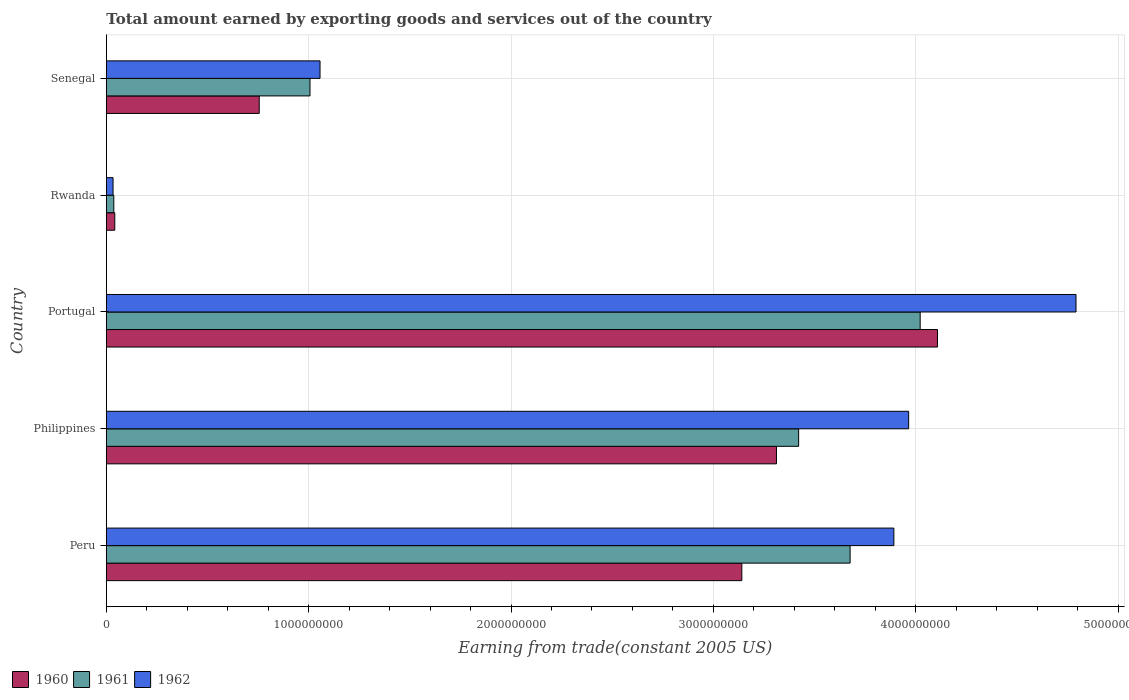How many groups of bars are there?
Provide a succinct answer. 5. Are the number of bars per tick equal to the number of legend labels?
Your response must be concise. Yes. Are the number of bars on each tick of the Y-axis equal?
Make the answer very short. Yes. How many bars are there on the 4th tick from the top?
Your response must be concise. 3. What is the total amount earned by exporting goods and services in 1960 in Portugal?
Your answer should be compact. 4.11e+09. Across all countries, what is the maximum total amount earned by exporting goods and services in 1961?
Give a very brief answer. 4.02e+09. Across all countries, what is the minimum total amount earned by exporting goods and services in 1961?
Ensure brevity in your answer.  3.69e+07. In which country was the total amount earned by exporting goods and services in 1960 maximum?
Provide a succinct answer. Portugal. In which country was the total amount earned by exporting goods and services in 1960 minimum?
Make the answer very short. Rwanda. What is the total total amount earned by exporting goods and services in 1960 in the graph?
Ensure brevity in your answer.  1.14e+1. What is the difference between the total amount earned by exporting goods and services in 1962 in Philippines and that in Rwanda?
Offer a very short reply. 3.93e+09. What is the difference between the total amount earned by exporting goods and services in 1962 in Philippines and the total amount earned by exporting goods and services in 1961 in Senegal?
Keep it short and to the point. 2.96e+09. What is the average total amount earned by exporting goods and services in 1961 per country?
Provide a short and direct response. 2.43e+09. What is the difference between the total amount earned by exporting goods and services in 1961 and total amount earned by exporting goods and services in 1960 in Portugal?
Keep it short and to the point. -8.56e+07. What is the ratio of the total amount earned by exporting goods and services in 1961 in Philippines to that in Rwanda?
Your response must be concise. 92.77. Is the total amount earned by exporting goods and services in 1961 in Peru less than that in Philippines?
Offer a very short reply. No. What is the difference between the highest and the second highest total amount earned by exporting goods and services in 1960?
Provide a succinct answer. 7.96e+08. What is the difference between the highest and the lowest total amount earned by exporting goods and services in 1961?
Your answer should be very brief. 3.98e+09. In how many countries, is the total amount earned by exporting goods and services in 1962 greater than the average total amount earned by exporting goods and services in 1962 taken over all countries?
Provide a short and direct response. 3. Is it the case that in every country, the sum of the total amount earned by exporting goods and services in 1962 and total amount earned by exporting goods and services in 1961 is greater than the total amount earned by exporting goods and services in 1960?
Your answer should be compact. Yes. How many bars are there?
Provide a succinct answer. 15. Are all the bars in the graph horizontal?
Your answer should be very brief. Yes. How many countries are there in the graph?
Your answer should be very brief. 5. Are the values on the major ticks of X-axis written in scientific E-notation?
Your answer should be very brief. No. Does the graph contain any zero values?
Provide a short and direct response. No. Does the graph contain grids?
Your answer should be compact. Yes. Where does the legend appear in the graph?
Make the answer very short. Bottom left. How many legend labels are there?
Your answer should be very brief. 3. What is the title of the graph?
Offer a terse response. Total amount earned by exporting goods and services out of the country. What is the label or title of the X-axis?
Provide a succinct answer. Earning from trade(constant 2005 US). What is the label or title of the Y-axis?
Give a very brief answer. Country. What is the Earning from trade(constant 2005 US) in 1960 in Peru?
Offer a terse response. 3.14e+09. What is the Earning from trade(constant 2005 US) in 1961 in Peru?
Give a very brief answer. 3.68e+09. What is the Earning from trade(constant 2005 US) in 1962 in Peru?
Offer a terse response. 3.89e+09. What is the Earning from trade(constant 2005 US) of 1960 in Philippines?
Keep it short and to the point. 3.31e+09. What is the Earning from trade(constant 2005 US) in 1961 in Philippines?
Give a very brief answer. 3.42e+09. What is the Earning from trade(constant 2005 US) in 1962 in Philippines?
Your answer should be compact. 3.97e+09. What is the Earning from trade(constant 2005 US) of 1960 in Portugal?
Offer a terse response. 4.11e+09. What is the Earning from trade(constant 2005 US) in 1961 in Portugal?
Make the answer very short. 4.02e+09. What is the Earning from trade(constant 2005 US) in 1962 in Portugal?
Provide a succinct answer. 4.79e+09. What is the Earning from trade(constant 2005 US) in 1960 in Rwanda?
Your answer should be compact. 4.18e+07. What is the Earning from trade(constant 2005 US) of 1961 in Rwanda?
Your answer should be compact. 3.69e+07. What is the Earning from trade(constant 2005 US) of 1962 in Rwanda?
Offer a very short reply. 3.32e+07. What is the Earning from trade(constant 2005 US) in 1960 in Senegal?
Ensure brevity in your answer.  7.56e+08. What is the Earning from trade(constant 2005 US) of 1961 in Senegal?
Give a very brief answer. 1.01e+09. What is the Earning from trade(constant 2005 US) in 1962 in Senegal?
Keep it short and to the point. 1.06e+09. Across all countries, what is the maximum Earning from trade(constant 2005 US) of 1960?
Offer a terse response. 4.11e+09. Across all countries, what is the maximum Earning from trade(constant 2005 US) of 1961?
Your response must be concise. 4.02e+09. Across all countries, what is the maximum Earning from trade(constant 2005 US) of 1962?
Provide a succinct answer. 4.79e+09. Across all countries, what is the minimum Earning from trade(constant 2005 US) in 1960?
Your response must be concise. 4.18e+07. Across all countries, what is the minimum Earning from trade(constant 2005 US) of 1961?
Provide a succinct answer. 3.69e+07. Across all countries, what is the minimum Earning from trade(constant 2005 US) in 1962?
Offer a very short reply. 3.32e+07. What is the total Earning from trade(constant 2005 US) in 1960 in the graph?
Provide a succinct answer. 1.14e+1. What is the total Earning from trade(constant 2005 US) of 1961 in the graph?
Your answer should be compact. 1.22e+1. What is the total Earning from trade(constant 2005 US) of 1962 in the graph?
Make the answer very short. 1.37e+1. What is the difference between the Earning from trade(constant 2005 US) of 1960 in Peru and that in Philippines?
Your answer should be very brief. -1.71e+08. What is the difference between the Earning from trade(constant 2005 US) in 1961 in Peru and that in Philippines?
Offer a terse response. 2.54e+08. What is the difference between the Earning from trade(constant 2005 US) of 1962 in Peru and that in Philippines?
Offer a very short reply. -7.32e+07. What is the difference between the Earning from trade(constant 2005 US) in 1960 in Peru and that in Portugal?
Offer a very short reply. -9.67e+08. What is the difference between the Earning from trade(constant 2005 US) of 1961 in Peru and that in Portugal?
Keep it short and to the point. -3.46e+08. What is the difference between the Earning from trade(constant 2005 US) of 1962 in Peru and that in Portugal?
Offer a very short reply. -9.00e+08. What is the difference between the Earning from trade(constant 2005 US) in 1960 in Peru and that in Rwanda?
Keep it short and to the point. 3.10e+09. What is the difference between the Earning from trade(constant 2005 US) of 1961 in Peru and that in Rwanda?
Give a very brief answer. 3.64e+09. What is the difference between the Earning from trade(constant 2005 US) in 1962 in Peru and that in Rwanda?
Make the answer very short. 3.86e+09. What is the difference between the Earning from trade(constant 2005 US) in 1960 in Peru and that in Senegal?
Your response must be concise. 2.38e+09. What is the difference between the Earning from trade(constant 2005 US) in 1961 in Peru and that in Senegal?
Provide a succinct answer. 2.67e+09. What is the difference between the Earning from trade(constant 2005 US) in 1962 in Peru and that in Senegal?
Ensure brevity in your answer.  2.84e+09. What is the difference between the Earning from trade(constant 2005 US) in 1960 in Philippines and that in Portugal?
Your response must be concise. -7.96e+08. What is the difference between the Earning from trade(constant 2005 US) in 1961 in Philippines and that in Portugal?
Offer a very short reply. -6.01e+08. What is the difference between the Earning from trade(constant 2005 US) in 1962 in Philippines and that in Portugal?
Offer a terse response. -8.27e+08. What is the difference between the Earning from trade(constant 2005 US) in 1960 in Philippines and that in Rwanda?
Keep it short and to the point. 3.27e+09. What is the difference between the Earning from trade(constant 2005 US) of 1961 in Philippines and that in Rwanda?
Your answer should be compact. 3.38e+09. What is the difference between the Earning from trade(constant 2005 US) of 1962 in Philippines and that in Rwanda?
Ensure brevity in your answer.  3.93e+09. What is the difference between the Earning from trade(constant 2005 US) of 1960 in Philippines and that in Senegal?
Ensure brevity in your answer.  2.56e+09. What is the difference between the Earning from trade(constant 2005 US) of 1961 in Philippines and that in Senegal?
Your response must be concise. 2.41e+09. What is the difference between the Earning from trade(constant 2005 US) in 1962 in Philippines and that in Senegal?
Offer a terse response. 2.91e+09. What is the difference between the Earning from trade(constant 2005 US) of 1960 in Portugal and that in Rwanda?
Keep it short and to the point. 4.07e+09. What is the difference between the Earning from trade(constant 2005 US) of 1961 in Portugal and that in Rwanda?
Your answer should be very brief. 3.98e+09. What is the difference between the Earning from trade(constant 2005 US) of 1962 in Portugal and that in Rwanda?
Offer a very short reply. 4.76e+09. What is the difference between the Earning from trade(constant 2005 US) of 1960 in Portugal and that in Senegal?
Provide a short and direct response. 3.35e+09. What is the difference between the Earning from trade(constant 2005 US) of 1961 in Portugal and that in Senegal?
Offer a terse response. 3.02e+09. What is the difference between the Earning from trade(constant 2005 US) of 1962 in Portugal and that in Senegal?
Keep it short and to the point. 3.74e+09. What is the difference between the Earning from trade(constant 2005 US) of 1960 in Rwanda and that in Senegal?
Keep it short and to the point. -7.14e+08. What is the difference between the Earning from trade(constant 2005 US) of 1961 in Rwanda and that in Senegal?
Offer a very short reply. -9.70e+08. What is the difference between the Earning from trade(constant 2005 US) of 1962 in Rwanda and that in Senegal?
Make the answer very short. -1.02e+09. What is the difference between the Earning from trade(constant 2005 US) of 1960 in Peru and the Earning from trade(constant 2005 US) of 1961 in Philippines?
Offer a terse response. -2.81e+08. What is the difference between the Earning from trade(constant 2005 US) in 1960 in Peru and the Earning from trade(constant 2005 US) in 1962 in Philippines?
Offer a terse response. -8.24e+08. What is the difference between the Earning from trade(constant 2005 US) of 1961 in Peru and the Earning from trade(constant 2005 US) of 1962 in Philippines?
Keep it short and to the point. -2.89e+08. What is the difference between the Earning from trade(constant 2005 US) of 1960 in Peru and the Earning from trade(constant 2005 US) of 1961 in Portugal?
Your answer should be very brief. -8.81e+08. What is the difference between the Earning from trade(constant 2005 US) in 1960 in Peru and the Earning from trade(constant 2005 US) in 1962 in Portugal?
Your response must be concise. -1.65e+09. What is the difference between the Earning from trade(constant 2005 US) in 1961 in Peru and the Earning from trade(constant 2005 US) in 1962 in Portugal?
Offer a very short reply. -1.12e+09. What is the difference between the Earning from trade(constant 2005 US) of 1960 in Peru and the Earning from trade(constant 2005 US) of 1961 in Rwanda?
Give a very brief answer. 3.10e+09. What is the difference between the Earning from trade(constant 2005 US) of 1960 in Peru and the Earning from trade(constant 2005 US) of 1962 in Rwanda?
Offer a terse response. 3.11e+09. What is the difference between the Earning from trade(constant 2005 US) in 1961 in Peru and the Earning from trade(constant 2005 US) in 1962 in Rwanda?
Offer a terse response. 3.64e+09. What is the difference between the Earning from trade(constant 2005 US) in 1960 in Peru and the Earning from trade(constant 2005 US) in 1961 in Senegal?
Your answer should be compact. 2.13e+09. What is the difference between the Earning from trade(constant 2005 US) of 1960 in Peru and the Earning from trade(constant 2005 US) of 1962 in Senegal?
Make the answer very short. 2.08e+09. What is the difference between the Earning from trade(constant 2005 US) of 1961 in Peru and the Earning from trade(constant 2005 US) of 1962 in Senegal?
Make the answer very short. 2.62e+09. What is the difference between the Earning from trade(constant 2005 US) in 1960 in Philippines and the Earning from trade(constant 2005 US) in 1961 in Portugal?
Ensure brevity in your answer.  -7.10e+08. What is the difference between the Earning from trade(constant 2005 US) of 1960 in Philippines and the Earning from trade(constant 2005 US) of 1962 in Portugal?
Your answer should be very brief. -1.48e+09. What is the difference between the Earning from trade(constant 2005 US) of 1961 in Philippines and the Earning from trade(constant 2005 US) of 1962 in Portugal?
Offer a very short reply. -1.37e+09. What is the difference between the Earning from trade(constant 2005 US) in 1960 in Philippines and the Earning from trade(constant 2005 US) in 1961 in Rwanda?
Offer a very short reply. 3.27e+09. What is the difference between the Earning from trade(constant 2005 US) of 1960 in Philippines and the Earning from trade(constant 2005 US) of 1962 in Rwanda?
Your answer should be very brief. 3.28e+09. What is the difference between the Earning from trade(constant 2005 US) of 1961 in Philippines and the Earning from trade(constant 2005 US) of 1962 in Rwanda?
Your answer should be compact. 3.39e+09. What is the difference between the Earning from trade(constant 2005 US) of 1960 in Philippines and the Earning from trade(constant 2005 US) of 1961 in Senegal?
Your answer should be very brief. 2.31e+09. What is the difference between the Earning from trade(constant 2005 US) in 1960 in Philippines and the Earning from trade(constant 2005 US) in 1962 in Senegal?
Provide a succinct answer. 2.26e+09. What is the difference between the Earning from trade(constant 2005 US) in 1961 in Philippines and the Earning from trade(constant 2005 US) in 1962 in Senegal?
Provide a succinct answer. 2.37e+09. What is the difference between the Earning from trade(constant 2005 US) in 1960 in Portugal and the Earning from trade(constant 2005 US) in 1961 in Rwanda?
Offer a terse response. 4.07e+09. What is the difference between the Earning from trade(constant 2005 US) of 1960 in Portugal and the Earning from trade(constant 2005 US) of 1962 in Rwanda?
Your answer should be very brief. 4.07e+09. What is the difference between the Earning from trade(constant 2005 US) of 1961 in Portugal and the Earning from trade(constant 2005 US) of 1962 in Rwanda?
Your answer should be compact. 3.99e+09. What is the difference between the Earning from trade(constant 2005 US) of 1960 in Portugal and the Earning from trade(constant 2005 US) of 1961 in Senegal?
Make the answer very short. 3.10e+09. What is the difference between the Earning from trade(constant 2005 US) of 1960 in Portugal and the Earning from trade(constant 2005 US) of 1962 in Senegal?
Provide a succinct answer. 3.05e+09. What is the difference between the Earning from trade(constant 2005 US) of 1961 in Portugal and the Earning from trade(constant 2005 US) of 1962 in Senegal?
Provide a short and direct response. 2.97e+09. What is the difference between the Earning from trade(constant 2005 US) in 1960 in Rwanda and the Earning from trade(constant 2005 US) in 1961 in Senegal?
Offer a terse response. -9.65e+08. What is the difference between the Earning from trade(constant 2005 US) of 1960 in Rwanda and the Earning from trade(constant 2005 US) of 1962 in Senegal?
Make the answer very short. -1.01e+09. What is the difference between the Earning from trade(constant 2005 US) in 1961 in Rwanda and the Earning from trade(constant 2005 US) in 1962 in Senegal?
Give a very brief answer. -1.02e+09. What is the average Earning from trade(constant 2005 US) of 1960 per country?
Provide a short and direct response. 2.27e+09. What is the average Earning from trade(constant 2005 US) in 1961 per country?
Keep it short and to the point. 2.43e+09. What is the average Earning from trade(constant 2005 US) in 1962 per country?
Make the answer very short. 2.75e+09. What is the difference between the Earning from trade(constant 2005 US) of 1960 and Earning from trade(constant 2005 US) of 1961 in Peru?
Ensure brevity in your answer.  -5.35e+08. What is the difference between the Earning from trade(constant 2005 US) in 1960 and Earning from trade(constant 2005 US) in 1962 in Peru?
Your response must be concise. -7.51e+08. What is the difference between the Earning from trade(constant 2005 US) of 1961 and Earning from trade(constant 2005 US) of 1962 in Peru?
Your answer should be very brief. -2.16e+08. What is the difference between the Earning from trade(constant 2005 US) of 1960 and Earning from trade(constant 2005 US) of 1961 in Philippines?
Keep it short and to the point. -1.10e+08. What is the difference between the Earning from trade(constant 2005 US) of 1960 and Earning from trade(constant 2005 US) of 1962 in Philippines?
Offer a terse response. -6.53e+08. What is the difference between the Earning from trade(constant 2005 US) of 1961 and Earning from trade(constant 2005 US) of 1962 in Philippines?
Your answer should be very brief. -5.44e+08. What is the difference between the Earning from trade(constant 2005 US) of 1960 and Earning from trade(constant 2005 US) of 1961 in Portugal?
Keep it short and to the point. 8.56e+07. What is the difference between the Earning from trade(constant 2005 US) in 1960 and Earning from trade(constant 2005 US) in 1962 in Portugal?
Keep it short and to the point. -6.85e+08. What is the difference between the Earning from trade(constant 2005 US) of 1961 and Earning from trade(constant 2005 US) of 1962 in Portugal?
Your answer should be compact. -7.70e+08. What is the difference between the Earning from trade(constant 2005 US) of 1960 and Earning from trade(constant 2005 US) of 1961 in Rwanda?
Your response must be concise. 4.89e+06. What is the difference between the Earning from trade(constant 2005 US) of 1960 and Earning from trade(constant 2005 US) of 1962 in Rwanda?
Provide a succinct answer. 8.56e+06. What is the difference between the Earning from trade(constant 2005 US) of 1961 and Earning from trade(constant 2005 US) of 1962 in Rwanda?
Give a very brief answer. 3.68e+06. What is the difference between the Earning from trade(constant 2005 US) in 1960 and Earning from trade(constant 2005 US) in 1961 in Senegal?
Your answer should be compact. -2.51e+08. What is the difference between the Earning from trade(constant 2005 US) of 1960 and Earning from trade(constant 2005 US) of 1962 in Senegal?
Offer a terse response. -3.00e+08. What is the difference between the Earning from trade(constant 2005 US) of 1961 and Earning from trade(constant 2005 US) of 1962 in Senegal?
Your answer should be very brief. -4.96e+07. What is the ratio of the Earning from trade(constant 2005 US) of 1960 in Peru to that in Philippines?
Your answer should be compact. 0.95. What is the ratio of the Earning from trade(constant 2005 US) in 1961 in Peru to that in Philippines?
Make the answer very short. 1.07. What is the ratio of the Earning from trade(constant 2005 US) in 1962 in Peru to that in Philippines?
Ensure brevity in your answer.  0.98. What is the ratio of the Earning from trade(constant 2005 US) of 1960 in Peru to that in Portugal?
Keep it short and to the point. 0.76. What is the ratio of the Earning from trade(constant 2005 US) of 1961 in Peru to that in Portugal?
Your answer should be compact. 0.91. What is the ratio of the Earning from trade(constant 2005 US) of 1962 in Peru to that in Portugal?
Provide a short and direct response. 0.81. What is the ratio of the Earning from trade(constant 2005 US) of 1960 in Peru to that in Rwanda?
Ensure brevity in your answer.  75.2. What is the ratio of the Earning from trade(constant 2005 US) of 1961 in Peru to that in Rwanda?
Your answer should be compact. 99.66. What is the ratio of the Earning from trade(constant 2005 US) of 1962 in Peru to that in Rwanda?
Your answer should be very brief. 117.21. What is the ratio of the Earning from trade(constant 2005 US) in 1960 in Peru to that in Senegal?
Your answer should be compact. 4.16. What is the ratio of the Earning from trade(constant 2005 US) of 1961 in Peru to that in Senegal?
Your answer should be very brief. 3.65. What is the ratio of the Earning from trade(constant 2005 US) of 1962 in Peru to that in Senegal?
Keep it short and to the point. 3.69. What is the ratio of the Earning from trade(constant 2005 US) in 1960 in Philippines to that in Portugal?
Provide a succinct answer. 0.81. What is the ratio of the Earning from trade(constant 2005 US) of 1961 in Philippines to that in Portugal?
Keep it short and to the point. 0.85. What is the ratio of the Earning from trade(constant 2005 US) of 1962 in Philippines to that in Portugal?
Your answer should be very brief. 0.83. What is the ratio of the Earning from trade(constant 2005 US) in 1960 in Philippines to that in Rwanda?
Your answer should be very brief. 79.29. What is the ratio of the Earning from trade(constant 2005 US) in 1961 in Philippines to that in Rwanda?
Offer a terse response. 92.77. What is the ratio of the Earning from trade(constant 2005 US) of 1962 in Philippines to that in Rwanda?
Your response must be concise. 119.41. What is the ratio of the Earning from trade(constant 2005 US) in 1960 in Philippines to that in Senegal?
Provide a short and direct response. 4.38. What is the ratio of the Earning from trade(constant 2005 US) of 1961 in Philippines to that in Senegal?
Give a very brief answer. 3.4. What is the ratio of the Earning from trade(constant 2005 US) of 1962 in Philippines to that in Senegal?
Keep it short and to the point. 3.75. What is the ratio of the Earning from trade(constant 2005 US) of 1960 in Portugal to that in Rwanda?
Provide a succinct answer. 98.35. What is the ratio of the Earning from trade(constant 2005 US) in 1961 in Portugal to that in Rwanda?
Offer a terse response. 109.05. What is the ratio of the Earning from trade(constant 2005 US) in 1962 in Portugal to that in Rwanda?
Provide a short and direct response. 144.32. What is the ratio of the Earning from trade(constant 2005 US) of 1960 in Portugal to that in Senegal?
Your answer should be compact. 5.44. What is the ratio of the Earning from trade(constant 2005 US) of 1961 in Portugal to that in Senegal?
Make the answer very short. 4. What is the ratio of the Earning from trade(constant 2005 US) in 1962 in Portugal to that in Senegal?
Make the answer very short. 4.54. What is the ratio of the Earning from trade(constant 2005 US) of 1960 in Rwanda to that in Senegal?
Provide a succinct answer. 0.06. What is the ratio of the Earning from trade(constant 2005 US) in 1961 in Rwanda to that in Senegal?
Make the answer very short. 0.04. What is the ratio of the Earning from trade(constant 2005 US) in 1962 in Rwanda to that in Senegal?
Provide a succinct answer. 0.03. What is the difference between the highest and the second highest Earning from trade(constant 2005 US) of 1960?
Provide a succinct answer. 7.96e+08. What is the difference between the highest and the second highest Earning from trade(constant 2005 US) in 1961?
Your answer should be very brief. 3.46e+08. What is the difference between the highest and the second highest Earning from trade(constant 2005 US) in 1962?
Offer a terse response. 8.27e+08. What is the difference between the highest and the lowest Earning from trade(constant 2005 US) in 1960?
Ensure brevity in your answer.  4.07e+09. What is the difference between the highest and the lowest Earning from trade(constant 2005 US) of 1961?
Your answer should be compact. 3.98e+09. What is the difference between the highest and the lowest Earning from trade(constant 2005 US) in 1962?
Offer a very short reply. 4.76e+09. 